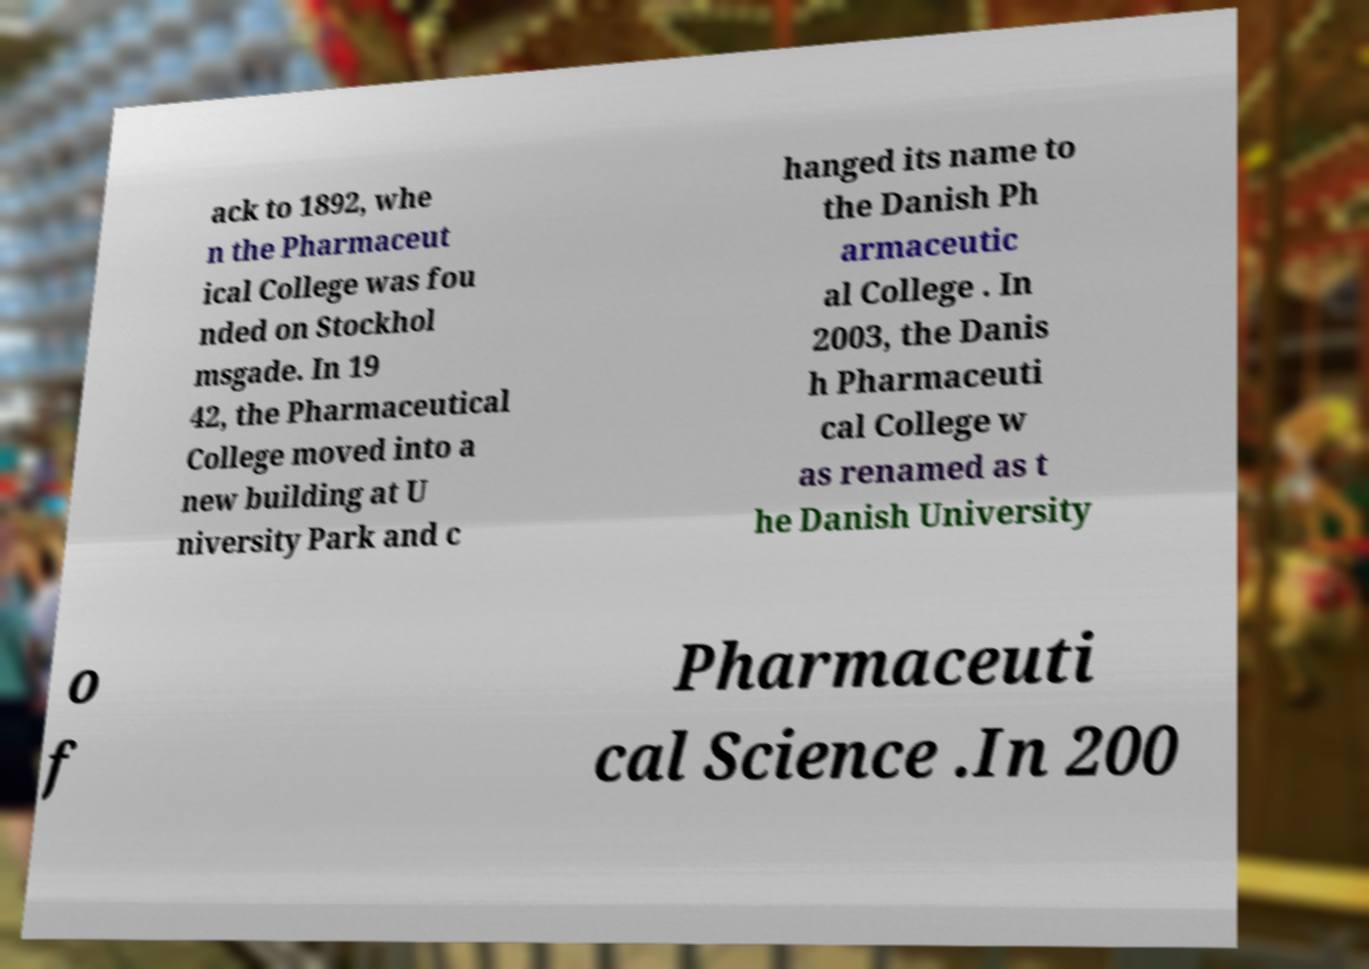Please identify and transcribe the text found in this image. ack to 1892, whe n the Pharmaceut ical College was fou nded on Stockhol msgade. In 19 42, the Pharmaceutical College moved into a new building at U niversity Park and c hanged its name to the Danish Ph armaceutic al College . In 2003, the Danis h Pharmaceuti cal College w as renamed as t he Danish University o f Pharmaceuti cal Science .In 200 